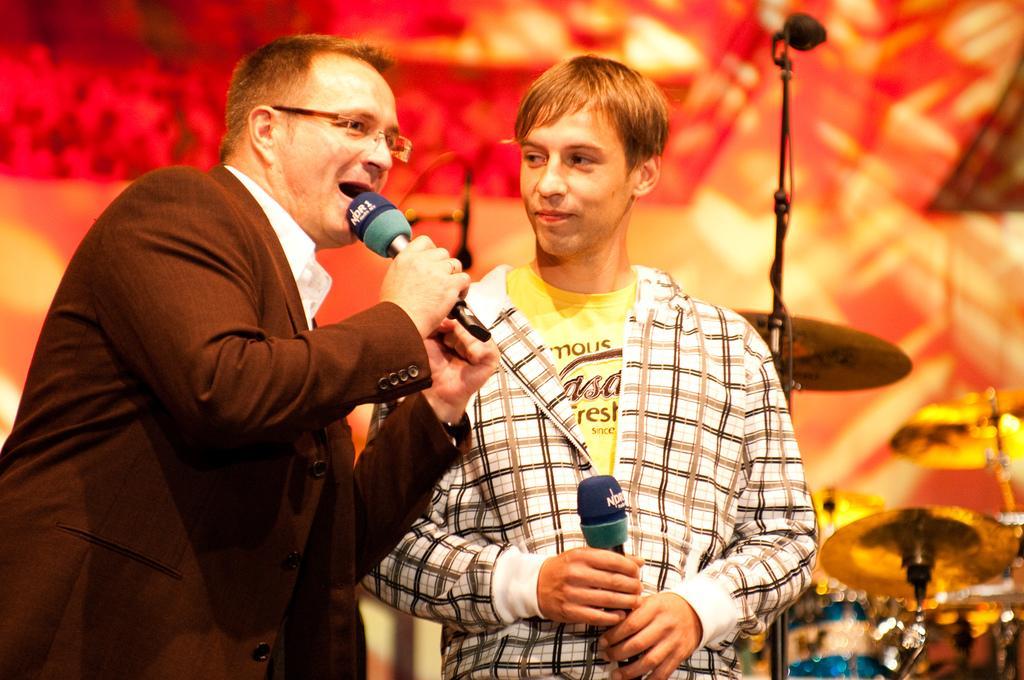In one or two sentences, can you explain what this image depicts? A man is talking with a mic in his hand. There is a boy beside him standing and holding a mic. 